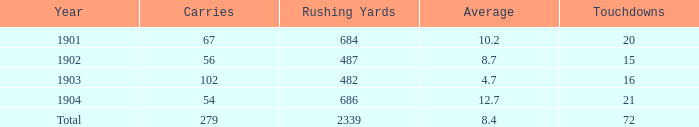Parse the full table. {'header': ['Year', 'Carries', 'Rushing Yards', 'Average', 'Touchdowns'], 'rows': [['1901', '67', '684', '10.2', '20'], ['1902', '56', '487', '8.7', '15'], ['1903', '102', '482', '4.7', '16'], ['1904', '54', '686', '12.7', '21'], ['Total', '279', '2339', '8.4', '72']]} What is the average number of carries that have more than 72 touchdowns? None. 